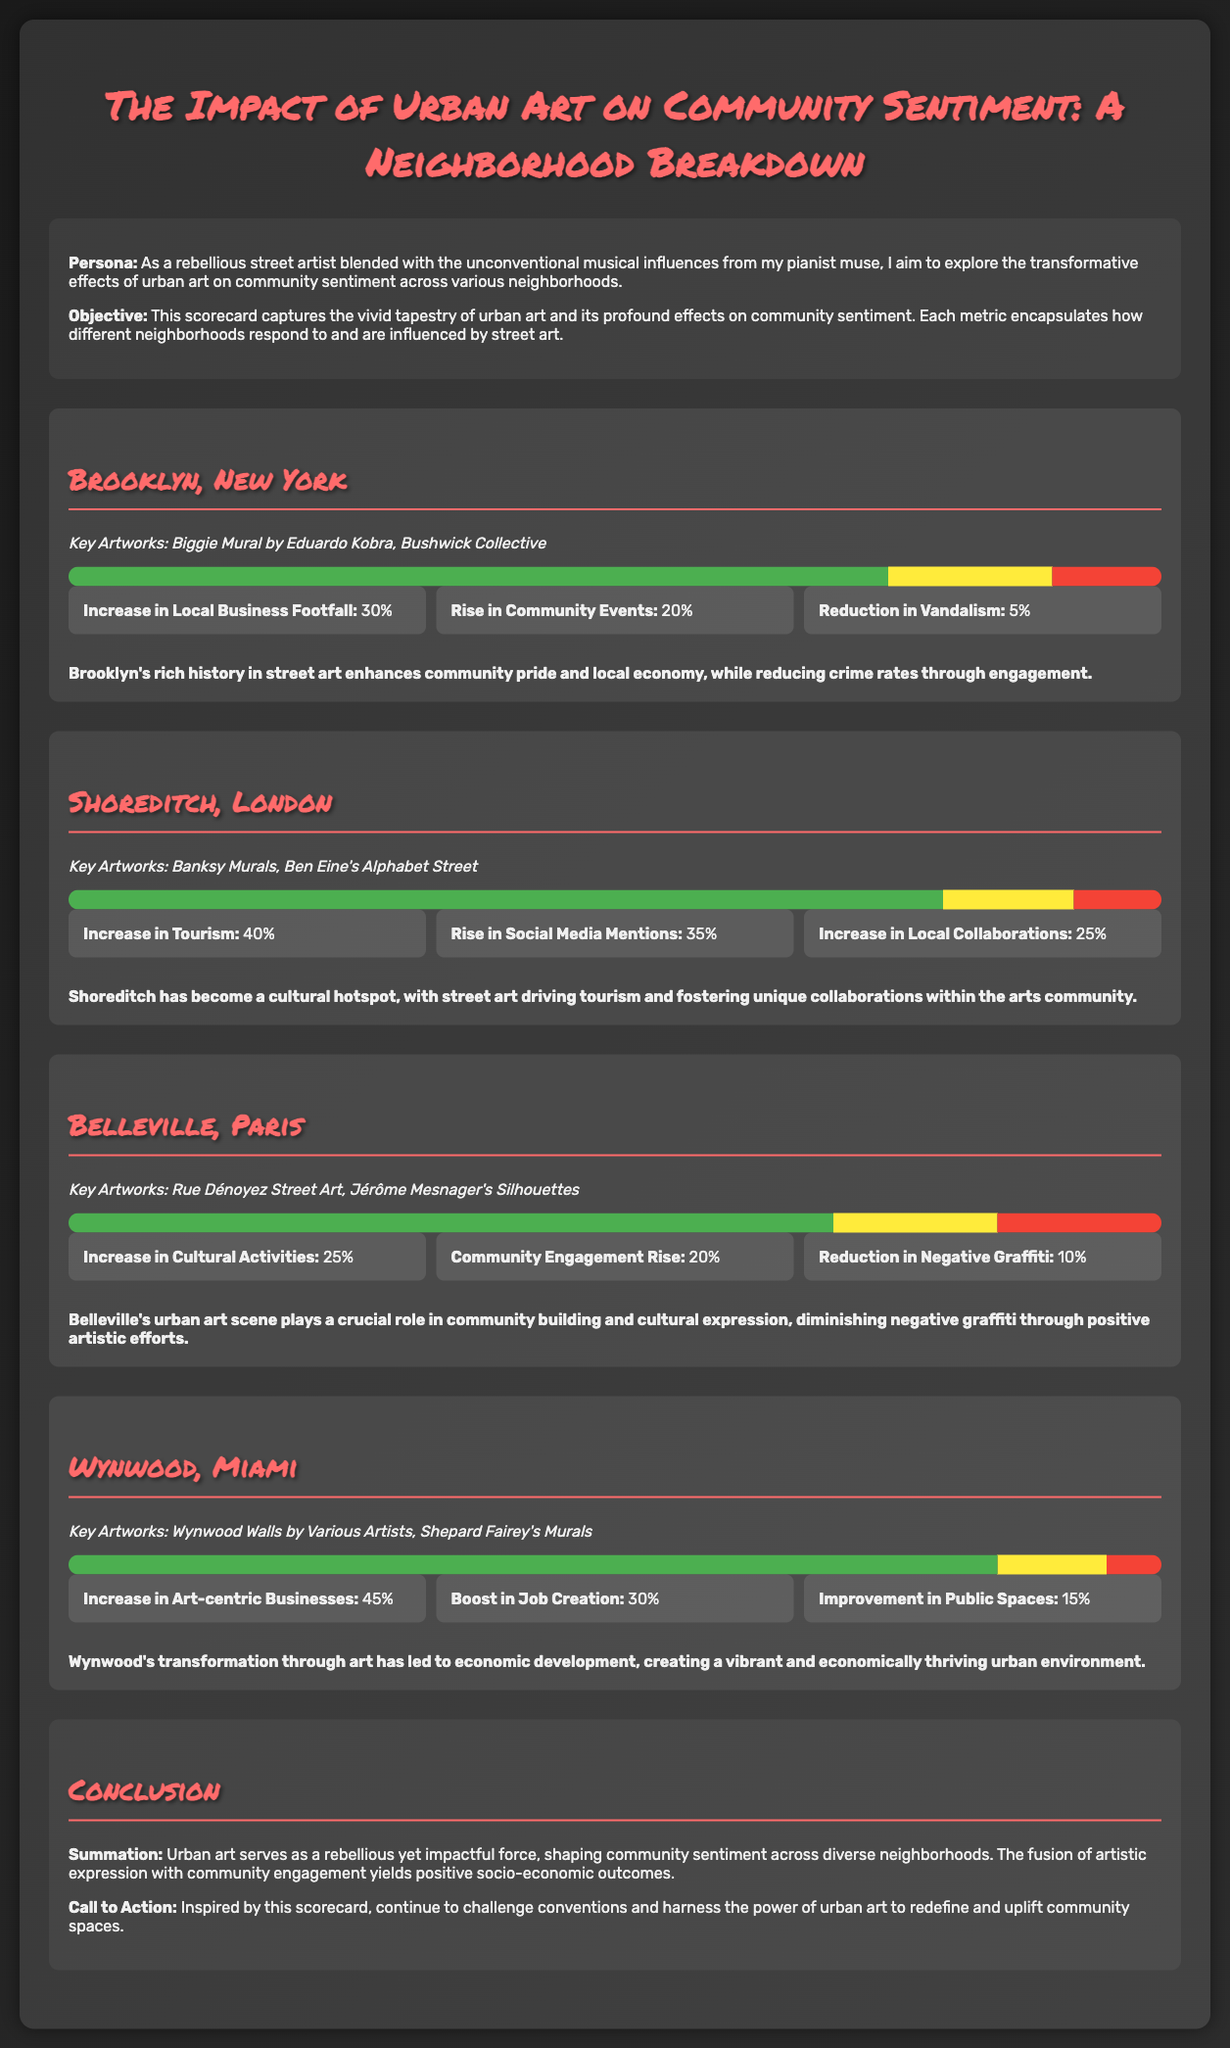What are the key artworks in Brooklyn? The key artworks mentioned for Brooklyn are the Biggie Mural by Eduardo Kobra and the Bushwick Collective.
Answer: Biggie Mural by Eduardo Kobra, Bushwick Collective What percentage of positive sentiment is reported for Wynwood? The positive sentiment percentage for Wynwood is displayed in the sentiment chart, which shows an 85% positive sentiment.
Answer: 85% Which neighborhood has the highest increase in tourism? The document states that Shoreditch has a 40% increase in tourism, which is the highest among the neighborhoods listed.
Answer: 40% What is the reduction in vandalism reported for Brooklyn? The scorecard notes a 5% reduction in vandalism specifically for the Brooklyn neighborhood.
Answer: 5% What percentage increase in local business footfall does Brooklyn report? According to the document, Brooklyn reports a 30% increase in local business footfall due to urban art.
Answer: 30% Which neighborhood has the most significant boost in job creation? The metrics indicate that Wynwood has a 30% boost in job creation, the highest of the neighborhoods mentioned.
Answer: 30% What is the overall conclusion about the impact of urban art? The conclusion summarizes that urban art shapes community sentiment and leads to positive socio-economic outcomes.
Answer: Positive socio-economic outcomes What key artwork is associated with Shoreditch? The key artworks listed for Shoreditch include Banksy Murals and Ben Eine's Alphabet Street.
Answer: Banksy Murals, Ben Eine's Alphabet Street What is the rise in community events reported for Brooklyn? Brooklyn reports a 20% increase in community events as indicated in the metrics section.
Answer: 20% 